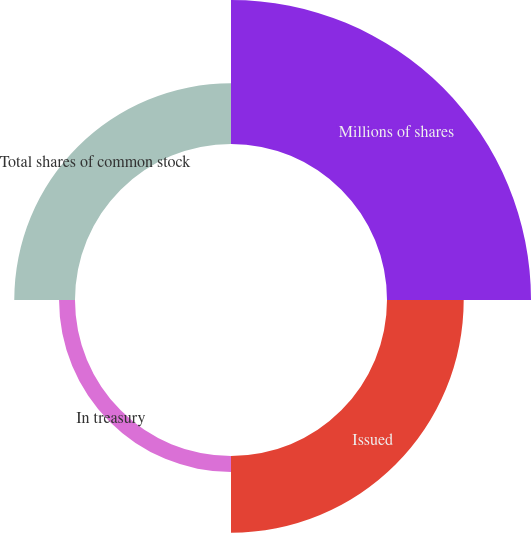Convert chart to OTSL. <chart><loc_0><loc_0><loc_500><loc_500><pie_chart><fcel>Millions of shares<fcel>Issued<fcel>In treasury<fcel>Total shares of common stock<nl><fcel>48.42%<fcel>25.79%<fcel>5.36%<fcel>20.42%<nl></chart> 